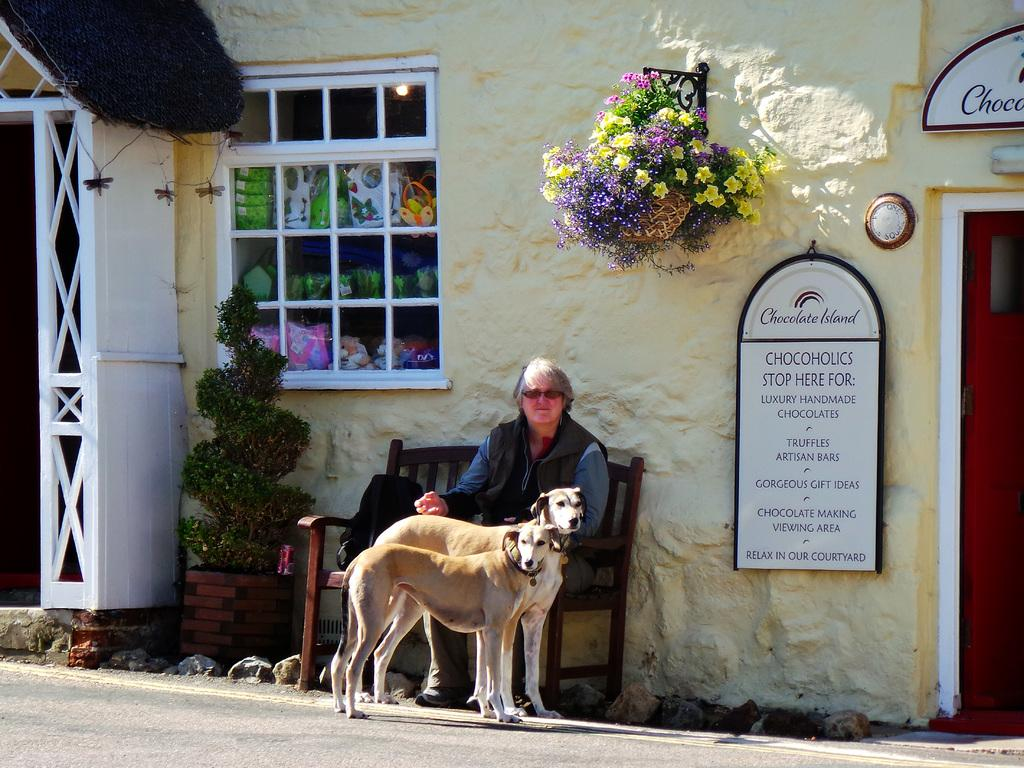What is the woman in the image doing? The woman is sitting on a bench in the image. What animals are present in the image? There are two dogs standing beside the woman. What type of decoration can be seen in the image? There are flowers in a basket in the image. Where are the flowers attached? The flowers are attached to a wall. What type of rifle can be seen in the image? There is no rifle present in the image. What causes the shock in the image? There is no shock depicted in the image. 